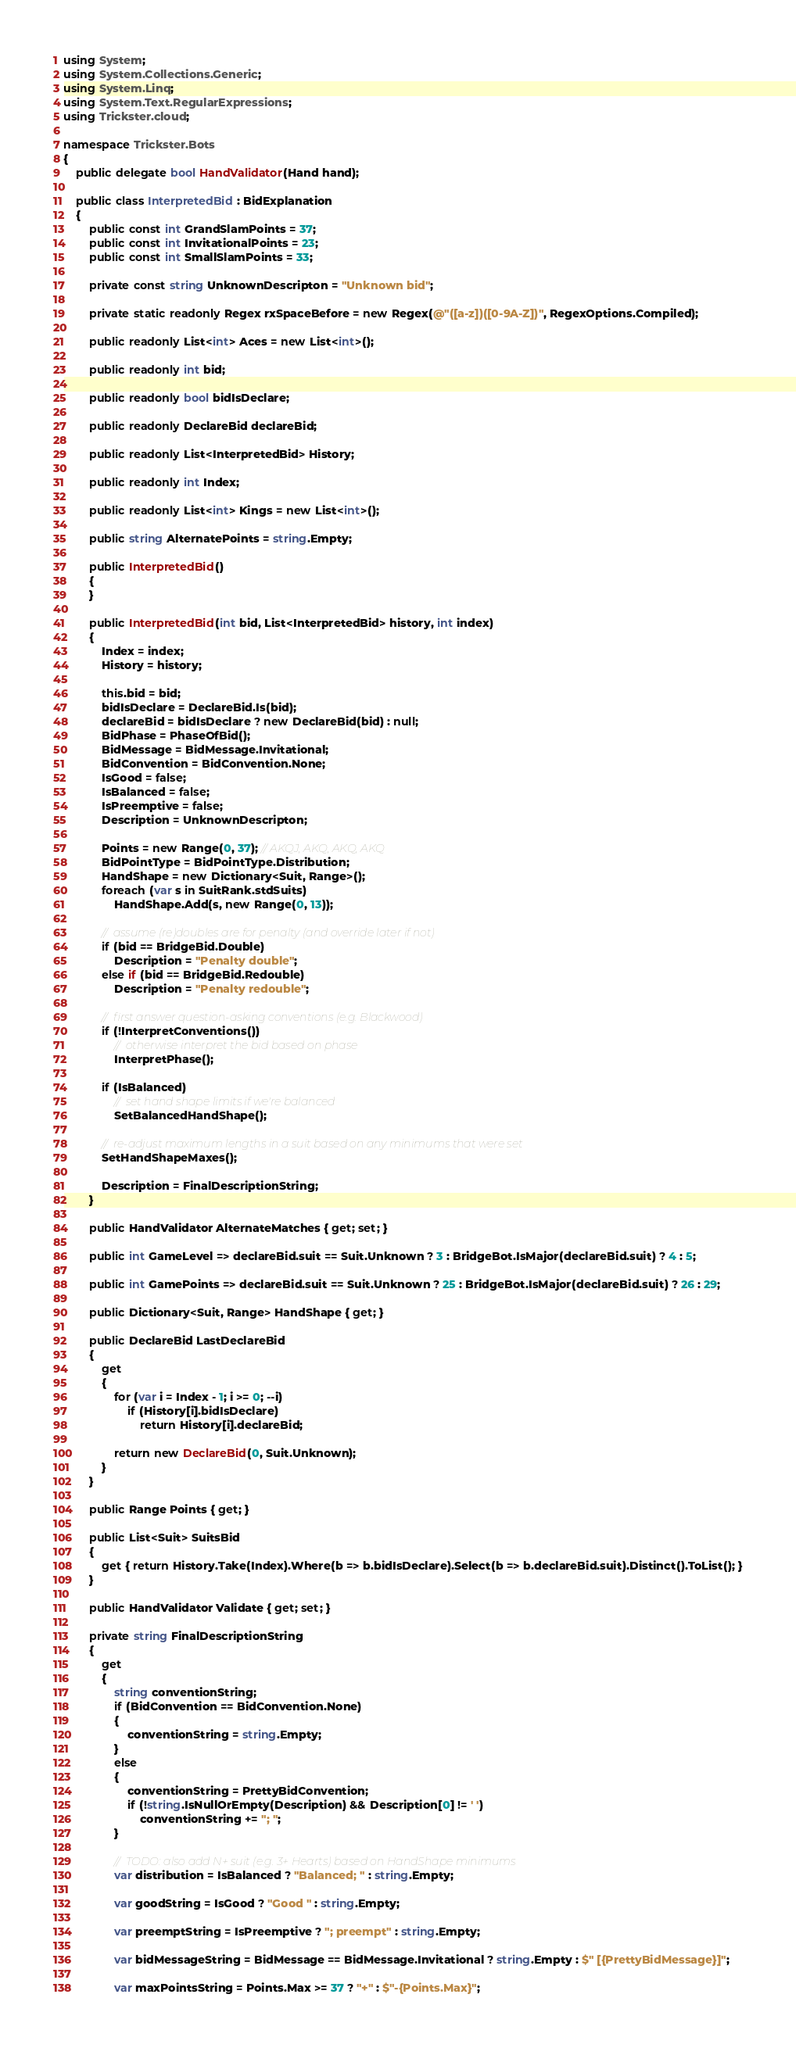Convert code to text. <code><loc_0><loc_0><loc_500><loc_500><_C#_>using System;
using System.Collections.Generic;
using System.Linq;
using System.Text.RegularExpressions;
using Trickster.cloud;

namespace Trickster.Bots
{
    public delegate bool HandValidator(Hand hand);

    public class InterpretedBid : BidExplanation
    {
        public const int GrandSlamPoints = 37;
        public const int InvitationalPoints = 23;
        public const int SmallSlamPoints = 33;

        private const string UnknownDescripton = "Unknown bid";

        private static readonly Regex rxSpaceBefore = new Regex(@"([a-z])([0-9A-Z])", RegexOptions.Compiled);

        public readonly List<int> Aces = new List<int>();

        public readonly int bid;

        public readonly bool bidIsDeclare;

        public readonly DeclareBid declareBid;

        public readonly List<InterpretedBid> History;

        public readonly int Index;

        public readonly List<int> Kings = new List<int>();

        public string AlternatePoints = string.Empty;

        public InterpretedBid()
        {
        }

        public InterpretedBid(int bid, List<InterpretedBid> history, int index)
        {
            Index = index;
            History = history;

            this.bid = bid;
            bidIsDeclare = DeclareBid.Is(bid);
            declareBid = bidIsDeclare ? new DeclareBid(bid) : null;
            BidPhase = PhaseOfBid();
            BidMessage = BidMessage.Invitational;
            BidConvention = BidConvention.None;
            IsGood = false;
            IsBalanced = false;
            IsPreemptive = false;
            Description = UnknownDescripton;

            Points = new Range(0, 37); // AKQJ, AKQ, AKQ, AKQ
            BidPointType = BidPointType.Distribution;
            HandShape = new Dictionary<Suit, Range>();
            foreach (var s in SuitRank.stdSuits)
                HandShape.Add(s, new Range(0, 13));

            //  assume (re)doubles are for penalty (and override later if not)
            if (bid == BridgeBid.Double)
                Description = "Penalty double";
            else if (bid == BridgeBid.Redouble)
                Description = "Penalty redouble";

            //  first answer question-asking conventions (e.g. Blackwood)
            if (!InterpretConventions())
                //  otherwise interpret the bid based on phase
                InterpretPhase();

            if (IsBalanced)
                //  set hand shape limits if we're balanced
                SetBalancedHandShape();

            //  re-adjust maximum lengths in a suit based on any minimums that were set
            SetHandShapeMaxes();

            Description = FinalDescriptionString;
        }

        public HandValidator AlternateMatches { get; set; }

        public int GameLevel => declareBid.suit == Suit.Unknown ? 3 : BridgeBot.IsMajor(declareBid.suit) ? 4 : 5;

        public int GamePoints => declareBid.suit == Suit.Unknown ? 25 : BridgeBot.IsMajor(declareBid.suit) ? 26 : 29;

        public Dictionary<Suit, Range> HandShape { get; }

        public DeclareBid LastDeclareBid
        {
            get
            {
                for (var i = Index - 1; i >= 0; --i)
                    if (History[i].bidIsDeclare)
                        return History[i].declareBid;

                return new DeclareBid(0, Suit.Unknown);
            }
        }

        public Range Points { get; }

        public List<Suit> SuitsBid
        {
            get { return History.Take(Index).Where(b => b.bidIsDeclare).Select(b => b.declareBid.suit).Distinct().ToList(); }
        }

        public HandValidator Validate { get; set; }

        private string FinalDescriptionString
        {
            get
            {
                string conventionString;
                if (BidConvention == BidConvention.None)
                {
                    conventionString = string.Empty;
                }
                else
                {
                    conventionString = PrettyBidConvention;
                    if (!string.IsNullOrEmpty(Description) && Description[0] != ' ')
                        conventionString += "; ";
                }

                //  TODO: also add N+ suit (e.g. 3+ Hearts) based on HandShape minimums
                var distribution = IsBalanced ? "Balanced; " : string.Empty;

                var goodString = IsGood ? "Good " : string.Empty;

                var preemptString = IsPreemptive ? "; preempt" : string.Empty;

                var bidMessageString = BidMessage == BidMessage.Invitational ? string.Empty : $" [{PrettyBidMessage}]";

                var maxPointsString = Points.Max >= 37 ? "+" : $"-{Points.Max}";</code> 